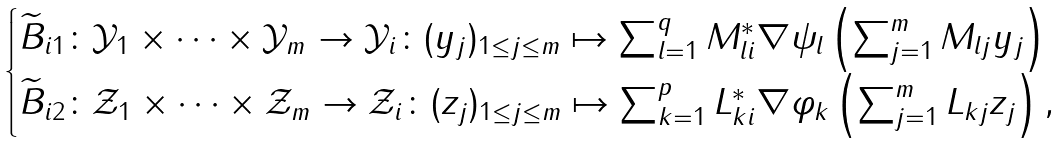<formula> <loc_0><loc_0><loc_500><loc_500>\begin{cases} \widetilde { B } _ { i 1 } \colon { \mathcal { Y } } _ { 1 } \times \cdots \times { \mathcal { Y } } _ { m } \to { \mathcal { Y } } _ { i } \colon ( y _ { j } ) _ { 1 \leq j \leq m } \mapsto \sum _ { l = 1 } ^ { q } M _ { l i } ^ { * } \nabla \psi _ { l } \left ( \sum _ { j = 1 } ^ { m } M _ { l j } y _ { j } \right ) \\ \widetilde { B } _ { i 2 } \colon { \mathcal { Z } } _ { 1 } \times \cdots \times { \mathcal { Z } } _ { m } \to { \mathcal { Z } } _ { i } \colon ( z _ { j } ) _ { 1 \leq j \leq m } \mapsto \sum _ { k = 1 } ^ { p } L _ { k i } ^ { * } \nabla \varphi _ { k } \left ( \sum _ { j = 1 } ^ { m } L _ { k j } z _ { j } \right ) , \end{cases}</formula> 